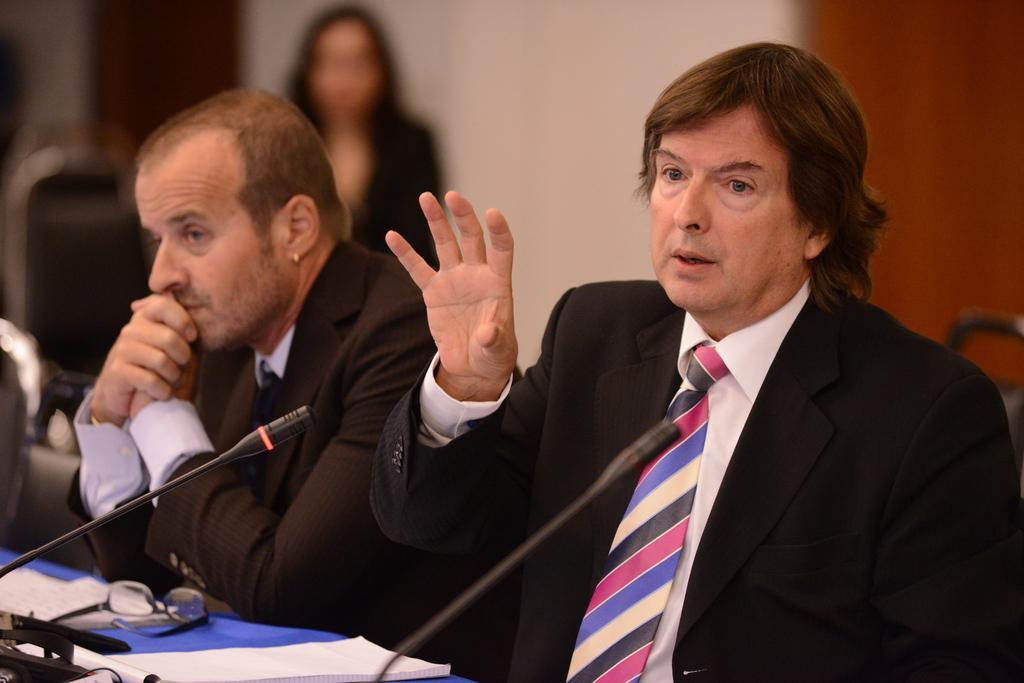Please provide a concise description of this image. In the center of the image we can see a two persons are sitting on a chair. At the bottom of the image we can see a table. On the table there is a spectacles, book, mice and some objects are there. In the background of the image wall is there. 